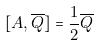<formula> <loc_0><loc_0><loc_500><loc_500>[ A , \overline { Q } ] = \frac { 1 } { 2 } \overline { Q }</formula> 